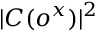Convert formula to latex. <formula><loc_0><loc_0><loc_500><loc_500>| C ( o ^ { x } ) | ^ { 2 }</formula> 